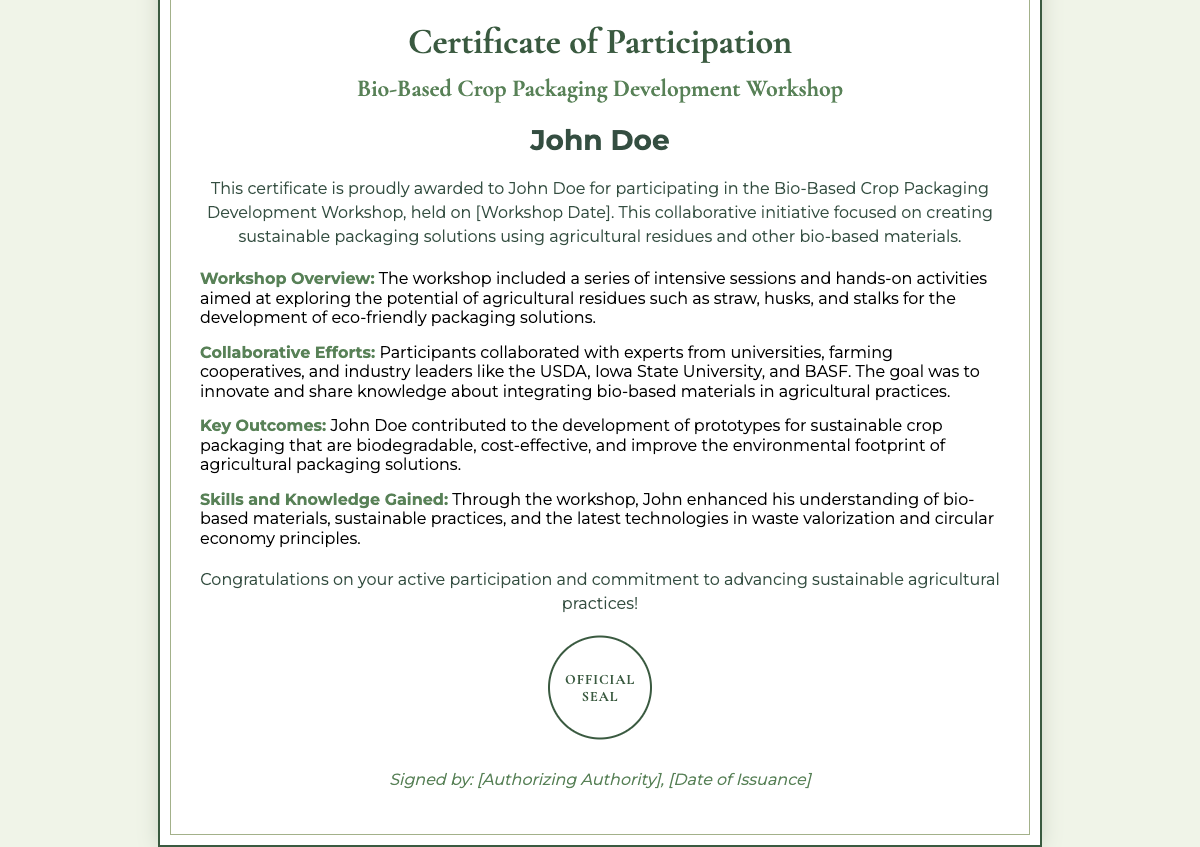what is the title of the workshop? The title of the workshop is mentioned prominently in the document's header.
Answer: Bio-Based Crop Packaging Development Workshop who is the participant's name? The participant's name is highlighted in a specific section of the certificate.
Answer: John Doe what is the significance of the workshop? The significance of the workshop is discussed in the introductory statement about its focus and goals.
Answer: Creating sustainable packaging solutions what date was the workshop held? The specific date when the workshop took place is noted in the introduction section of the certificate.
Answer: [Workshop Date] which agricultural residues were explored? The document lists specific agricultural residues that were the focus during the workshop.
Answer: Straw, husks, and stalks who were the collaborators involved? The document mentions various types of collaborators and key organizations involved in the initiative.
Answer: USDA, Iowa State University, and BASF what type of prototypes were developed? The details section outlines the focus of the prototypes created during the workshop.
Answer: Sustainable crop packaging what skills were gained from the workshop? The section on skills gained explains the knowledge that the participant enhanced through their involvement.
Answer: Understanding of bio-based materials who authorized the certificate? The authorization for the certificate is typically noted in the footer section of such documents.
Answer: [Authorizing Authority] 